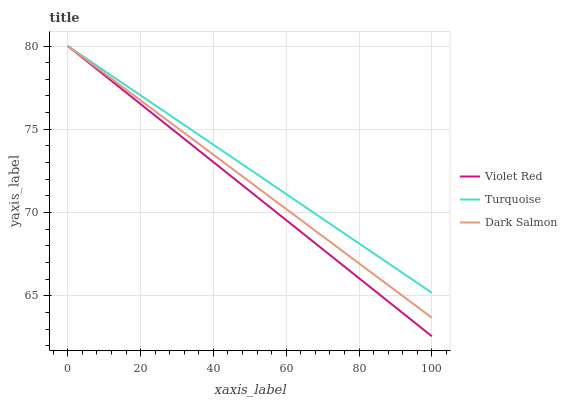Does Violet Red have the minimum area under the curve?
Answer yes or no. Yes. Does Turquoise have the maximum area under the curve?
Answer yes or no. Yes. Does Dark Salmon have the minimum area under the curve?
Answer yes or no. No. Does Dark Salmon have the maximum area under the curve?
Answer yes or no. No. Is Turquoise the smoothest?
Answer yes or no. Yes. Is Dark Salmon the roughest?
Answer yes or no. Yes. Is Dark Salmon the smoothest?
Answer yes or no. No. Is Turquoise the roughest?
Answer yes or no. No. Does Violet Red have the lowest value?
Answer yes or no. Yes. Does Dark Salmon have the lowest value?
Answer yes or no. No. Does Dark Salmon have the highest value?
Answer yes or no. Yes. Does Turquoise intersect Violet Red?
Answer yes or no. Yes. Is Turquoise less than Violet Red?
Answer yes or no. No. Is Turquoise greater than Violet Red?
Answer yes or no. No. 